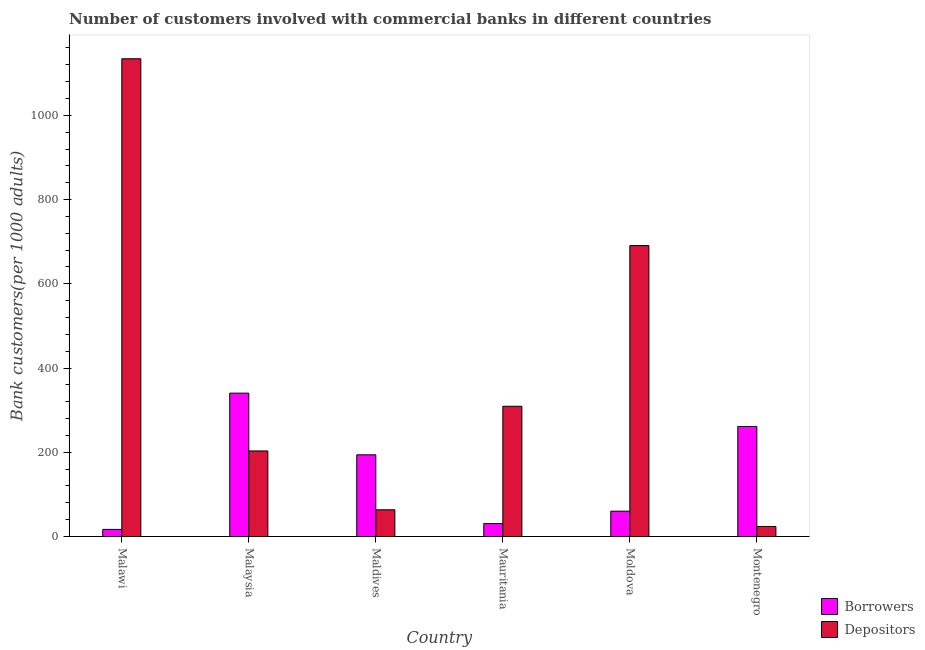Are the number of bars per tick equal to the number of legend labels?
Keep it short and to the point. Yes. Are the number of bars on each tick of the X-axis equal?
Ensure brevity in your answer.  Yes. How many bars are there on the 5th tick from the right?
Keep it short and to the point. 2. What is the label of the 5th group of bars from the left?
Your response must be concise. Moldova. What is the number of borrowers in Maldives?
Provide a succinct answer. 193.96. Across all countries, what is the maximum number of borrowers?
Keep it short and to the point. 340.42. Across all countries, what is the minimum number of borrowers?
Your answer should be very brief. 16.9. In which country was the number of depositors maximum?
Provide a short and direct response. Malawi. In which country was the number of borrowers minimum?
Give a very brief answer. Malawi. What is the total number of depositors in the graph?
Offer a terse response. 2424.78. What is the difference between the number of depositors in Malaysia and that in Maldives?
Your response must be concise. 139.73. What is the difference between the number of depositors in Maldives and the number of borrowers in Mauritania?
Give a very brief answer. 32.75. What is the average number of borrowers per country?
Offer a terse response. 150.55. What is the difference between the number of borrowers and number of depositors in Mauritania?
Make the answer very short. -278.55. In how many countries, is the number of depositors greater than 120 ?
Keep it short and to the point. 4. What is the ratio of the number of depositors in Malawi to that in Maldives?
Provide a succinct answer. 17.88. Is the number of depositors in Maldives less than that in Moldova?
Your response must be concise. Yes. Is the difference between the number of borrowers in Malaysia and Moldova greater than the difference between the number of depositors in Malaysia and Moldova?
Keep it short and to the point. Yes. What is the difference between the highest and the second highest number of depositors?
Provide a short and direct response. 443.6. What is the difference between the highest and the lowest number of borrowers?
Give a very brief answer. 323.52. Is the sum of the number of depositors in Malaysia and Montenegro greater than the maximum number of borrowers across all countries?
Keep it short and to the point. No. What does the 1st bar from the left in Moldova represents?
Your answer should be compact. Borrowers. What does the 1st bar from the right in Maldives represents?
Offer a very short reply. Depositors. Are all the bars in the graph horizontal?
Your response must be concise. No. What is the difference between two consecutive major ticks on the Y-axis?
Your answer should be very brief. 200. Does the graph contain any zero values?
Keep it short and to the point. No. Where does the legend appear in the graph?
Provide a succinct answer. Bottom right. How many legend labels are there?
Offer a terse response. 2. What is the title of the graph?
Your answer should be very brief. Number of customers involved with commercial banks in different countries. What is the label or title of the X-axis?
Your response must be concise. Country. What is the label or title of the Y-axis?
Provide a short and direct response. Bank customers(per 1000 adults). What is the Bank customers(per 1000 adults) of Borrowers in Malawi?
Your response must be concise. 16.9. What is the Bank customers(per 1000 adults) in Depositors in Malawi?
Your answer should be very brief. 1134.4. What is the Bank customers(per 1000 adults) in Borrowers in Malaysia?
Provide a succinct answer. 340.42. What is the Bank customers(per 1000 adults) in Depositors in Malaysia?
Keep it short and to the point. 203.17. What is the Bank customers(per 1000 adults) of Borrowers in Maldives?
Your response must be concise. 193.96. What is the Bank customers(per 1000 adults) of Depositors in Maldives?
Provide a succinct answer. 63.43. What is the Bank customers(per 1000 adults) of Borrowers in Mauritania?
Provide a short and direct response. 30.68. What is the Bank customers(per 1000 adults) in Depositors in Mauritania?
Your answer should be compact. 309.23. What is the Bank customers(per 1000 adults) of Borrowers in Moldova?
Ensure brevity in your answer.  60.13. What is the Bank customers(per 1000 adults) of Depositors in Moldova?
Provide a short and direct response. 690.79. What is the Bank customers(per 1000 adults) in Borrowers in Montenegro?
Offer a terse response. 261.24. What is the Bank customers(per 1000 adults) of Depositors in Montenegro?
Ensure brevity in your answer.  23.75. Across all countries, what is the maximum Bank customers(per 1000 adults) in Borrowers?
Provide a short and direct response. 340.42. Across all countries, what is the maximum Bank customers(per 1000 adults) in Depositors?
Provide a short and direct response. 1134.4. Across all countries, what is the minimum Bank customers(per 1000 adults) in Borrowers?
Provide a succinct answer. 16.9. Across all countries, what is the minimum Bank customers(per 1000 adults) in Depositors?
Keep it short and to the point. 23.75. What is the total Bank customers(per 1000 adults) of Borrowers in the graph?
Provide a short and direct response. 903.32. What is the total Bank customers(per 1000 adults) of Depositors in the graph?
Make the answer very short. 2424.78. What is the difference between the Bank customers(per 1000 adults) in Borrowers in Malawi and that in Malaysia?
Your response must be concise. -323.52. What is the difference between the Bank customers(per 1000 adults) of Depositors in Malawi and that in Malaysia?
Offer a terse response. 931.23. What is the difference between the Bank customers(per 1000 adults) in Borrowers in Malawi and that in Maldives?
Offer a very short reply. -177.07. What is the difference between the Bank customers(per 1000 adults) in Depositors in Malawi and that in Maldives?
Your answer should be very brief. 1070.96. What is the difference between the Bank customers(per 1000 adults) of Borrowers in Malawi and that in Mauritania?
Make the answer very short. -13.79. What is the difference between the Bank customers(per 1000 adults) of Depositors in Malawi and that in Mauritania?
Provide a short and direct response. 825.16. What is the difference between the Bank customers(per 1000 adults) of Borrowers in Malawi and that in Moldova?
Ensure brevity in your answer.  -43.24. What is the difference between the Bank customers(per 1000 adults) of Depositors in Malawi and that in Moldova?
Offer a very short reply. 443.6. What is the difference between the Bank customers(per 1000 adults) in Borrowers in Malawi and that in Montenegro?
Make the answer very short. -244.34. What is the difference between the Bank customers(per 1000 adults) in Depositors in Malawi and that in Montenegro?
Offer a terse response. 1110.65. What is the difference between the Bank customers(per 1000 adults) of Borrowers in Malaysia and that in Maldives?
Your answer should be very brief. 146.45. What is the difference between the Bank customers(per 1000 adults) of Depositors in Malaysia and that in Maldives?
Give a very brief answer. 139.73. What is the difference between the Bank customers(per 1000 adults) in Borrowers in Malaysia and that in Mauritania?
Offer a very short reply. 309.73. What is the difference between the Bank customers(per 1000 adults) of Depositors in Malaysia and that in Mauritania?
Give a very brief answer. -106.06. What is the difference between the Bank customers(per 1000 adults) in Borrowers in Malaysia and that in Moldova?
Your response must be concise. 280.28. What is the difference between the Bank customers(per 1000 adults) in Depositors in Malaysia and that in Moldova?
Provide a short and direct response. -487.63. What is the difference between the Bank customers(per 1000 adults) in Borrowers in Malaysia and that in Montenegro?
Give a very brief answer. 79.18. What is the difference between the Bank customers(per 1000 adults) in Depositors in Malaysia and that in Montenegro?
Make the answer very short. 179.42. What is the difference between the Bank customers(per 1000 adults) of Borrowers in Maldives and that in Mauritania?
Keep it short and to the point. 163.28. What is the difference between the Bank customers(per 1000 adults) in Depositors in Maldives and that in Mauritania?
Keep it short and to the point. -245.8. What is the difference between the Bank customers(per 1000 adults) of Borrowers in Maldives and that in Moldova?
Ensure brevity in your answer.  133.83. What is the difference between the Bank customers(per 1000 adults) of Depositors in Maldives and that in Moldova?
Your answer should be compact. -627.36. What is the difference between the Bank customers(per 1000 adults) of Borrowers in Maldives and that in Montenegro?
Provide a succinct answer. -67.27. What is the difference between the Bank customers(per 1000 adults) in Depositors in Maldives and that in Montenegro?
Your response must be concise. 39.69. What is the difference between the Bank customers(per 1000 adults) of Borrowers in Mauritania and that in Moldova?
Give a very brief answer. -29.45. What is the difference between the Bank customers(per 1000 adults) of Depositors in Mauritania and that in Moldova?
Keep it short and to the point. -381.56. What is the difference between the Bank customers(per 1000 adults) in Borrowers in Mauritania and that in Montenegro?
Give a very brief answer. -230.55. What is the difference between the Bank customers(per 1000 adults) in Depositors in Mauritania and that in Montenegro?
Keep it short and to the point. 285.49. What is the difference between the Bank customers(per 1000 adults) in Borrowers in Moldova and that in Montenegro?
Your answer should be compact. -201.1. What is the difference between the Bank customers(per 1000 adults) of Depositors in Moldova and that in Montenegro?
Offer a very short reply. 667.05. What is the difference between the Bank customers(per 1000 adults) in Borrowers in Malawi and the Bank customers(per 1000 adults) in Depositors in Malaysia?
Keep it short and to the point. -186.27. What is the difference between the Bank customers(per 1000 adults) of Borrowers in Malawi and the Bank customers(per 1000 adults) of Depositors in Maldives?
Provide a succinct answer. -46.54. What is the difference between the Bank customers(per 1000 adults) of Borrowers in Malawi and the Bank customers(per 1000 adults) of Depositors in Mauritania?
Your response must be concise. -292.34. What is the difference between the Bank customers(per 1000 adults) of Borrowers in Malawi and the Bank customers(per 1000 adults) of Depositors in Moldova?
Give a very brief answer. -673.9. What is the difference between the Bank customers(per 1000 adults) in Borrowers in Malawi and the Bank customers(per 1000 adults) in Depositors in Montenegro?
Your response must be concise. -6.85. What is the difference between the Bank customers(per 1000 adults) of Borrowers in Malaysia and the Bank customers(per 1000 adults) of Depositors in Maldives?
Provide a short and direct response. 276.98. What is the difference between the Bank customers(per 1000 adults) in Borrowers in Malaysia and the Bank customers(per 1000 adults) in Depositors in Mauritania?
Ensure brevity in your answer.  31.18. What is the difference between the Bank customers(per 1000 adults) of Borrowers in Malaysia and the Bank customers(per 1000 adults) of Depositors in Moldova?
Provide a short and direct response. -350.38. What is the difference between the Bank customers(per 1000 adults) of Borrowers in Malaysia and the Bank customers(per 1000 adults) of Depositors in Montenegro?
Your response must be concise. 316.67. What is the difference between the Bank customers(per 1000 adults) in Borrowers in Maldives and the Bank customers(per 1000 adults) in Depositors in Mauritania?
Your response must be concise. -115.27. What is the difference between the Bank customers(per 1000 adults) in Borrowers in Maldives and the Bank customers(per 1000 adults) in Depositors in Moldova?
Ensure brevity in your answer.  -496.83. What is the difference between the Bank customers(per 1000 adults) of Borrowers in Maldives and the Bank customers(per 1000 adults) of Depositors in Montenegro?
Provide a succinct answer. 170.21. What is the difference between the Bank customers(per 1000 adults) in Borrowers in Mauritania and the Bank customers(per 1000 adults) in Depositors in Moldova?
Your answer should be compact. -660.11. What is the difference between the Bank customers(per 1000 adults) in Borrowers in Mauritania and the Bank customers(per 1000 adults) in Depositors in Montenegro?
Offer a terse response. 6.93. What is the difference between the Bank customers(per 1000 adults) of Borrowers in Moldova and the Bank customers(per 1000 adults) of Depositors in Montenegro?
Offer a terse response. 36.39. What is the average Bank customers(per 1000 adults) in Borrowers per country?
Keep it short and to the point. 150.55. What is the average Bank customers(per 1000 adults) of Depositors per country?
Your answer should be very brief. 404.13. What is the difference between the Bank customers(per 1000 adults) of Borrowers and Bank customers(per 1000 adults) of Depositors in Malawi?
Offer a very short reply. -1117.5. What is the difference between the Bank customers(per 1000 adults) in Borrowers and Bank customers(per 1000 adults) in Depositors in Malaysia?
Your response must be concise. 137.25. What is the difference between the Bank customers(per 1000 adults) in Borrowers and Bank customers(per 1000 adults) in Depositors in Maldives?
Offer a terse response. 130.53. What is the difference between the Bank customers(per 1000 adults) in Borrowers and Bank customers(per 1000 adults) in Depositors in Mauritania?
Ensure brevity in your answer.  -278.55. What is the difference between the Bank customers(per 1000 adults) of Borrowers and Bank customers(per 1000 adults) of Depositors in Moldova?
Make the answer very short. -630.66. What is the difference between the Bank customers(per 1000 adults) of Borrowers and Bank customers(per 1000 adults) of Depositors in Montenegro?
Your answer should be very brief. 237.49. What is the ratio of the Bank customers(per 1000 adults) of Borrowers in Malawi to that in Malaysia?
Your answer should be compact. 0.05. What is the ratio of the Bank customers(per 1000 adults) in Depositors in Malawi to that in Malaysia?
Offer a very short reply. 5.58. What is the ratio of the Bank customers(per 1000 adults) of Borrowers in Malawi to that in Maldives?
Give a very brief answer. 0.09. What is the ratio of the Bank customers(per 1000 adults) in Depositors in Malawi to that in Maldives?
Provide a short and direct response. 17.88. What is the ratio of the Bank customers(per 1000 adults) of Borrowers in Malawi to that in Mauritania?
Make the answer very short. 0.55. What is the ratio of the Bank customers(per 1000 adults) in Depositors in Malawi to that in Mauritania?
Provide a short and direct response. 3.67. What is the ratio of the Bank customers(per 1000 adults) in Borrowers in Malawi to that in Moldova?
Keep it short and to the point. 0.28. What is the ratio of the Bank customers(per 1000 adults) of Depositors in Malawi to that in Moldova?
Offer a terse response. 1.64. What is the ratio of the Bank customers(per 1000 adults) of Borrowers in Malawi to that in Montenegro?
Your response must be concise. 0.06. What is the ratio of the Bank customers(per 1000 adults) in Depositors in Malawi to that in Montenegro?
Make the answer very short. 47.77. What is the ratio of the Bank customers(per 1000 adults) in Borrowers in Malaysia to that in Maldives?
Your response must be concise. 1.76. What is the ratio of the Bank customers(per 1000 adults) of Depositors in Malaysia to that in Maldives?
Provide a succinct answer. 3.2. What is the ratio of the Bank customers(per 1000 adults) of Borrowers in Malaysia to that in Mauritania?
Offer a terse response. 11.1. What is the ratio of the Bank customers(per 1000 adults) of Depositors in Malaysia to that in Mauritania?
Your response must be concise. 0.66. What is the ratio of the Bank customers(per 1000 adults) of Borrowers in Malaysia to that in Moldova?
Provide a short and direct response. 5.66. What is the ratio of the Bank customers(per 1000 adults) of Depositors in Malaysia to that in Moldova?
Provide a short and direct response. 0.29. What is the ratio of the Bank customers(per 1000 adults) in Borrowers in Malaysia to that in Montenegro?
Make the answer very short. 1.3. What is the ratio of the Bank customers(per 1000 adults) in Depositors in Malaysia to that in Montenegro?
Offer a terse response. 8.56. What is the ratio of the Bank customers(per 1000 adults) in Borrowers in Maldives to that in Mauritania?
Your answer should be compact. 6.32. What is the ratio of the Bank customers(per 1000 adults) in Depositors in Maldives to that in Mauritania?
Ensure brevity in your answer.  0.21. What is the ratio of the Bank customers(per 1000 adults) in Borrowers in Maldives to that in Moldova?
Offer a very short reply. 3.23. What is the ratio of the Bank customers(per 1000 adults) of Depositors in Maldives to that in Moldova?
Keep it short and to the point. 0.09. What is the ratio of the Bank customers(per 1000 adults) of Borrowers in Maldives to that in Montenegro?
Your response must be concise. 0.74. What is the ratio of the Bank customers(per 1000 adults) in Depositors in Maldives to that in Montenegro?
Ensure brevity in your answer.  2.67. What is the ratio of the Bank customers(per 1000 adults) of Borrowers in Mauritania to that in Moldova?
Make the answer very short. 0.51. What is the ratio of the Bank customers(per 1000 adults) of Depositors in Mauritania to that in Moldova?
Provide a succinct answer. 0.45. What is the ratio of the Bank customers(per 1000 adults) of Borrowers in Mauritania to that in Montenegro?
Offer a very short reply. 0.12. What is the ratio of the Bank customers(per 1000 adults) in Depositors in Mauritania to that in Montenegro?
Offer a terse response. 13.02. What is the ratio of the Bank customers(per 1000 adults) in Borrowers in Moldova to that in Montenegro?
Your answer should be very brief. 0.23. What is the ratio of the Bank customers(per 1000 adults) in Depositors in Moldova to that in Montenegro?
Offer a very short reply. 29.09. What is the difference between the highest and the second highest Bank customers(per 1000 adults) of Borrowers?
Your answer should be compact. 79.18. What is the difference between the highest and the second highest Bank customers(per 1000 adults) in Depositors?
Provide a succinct answer. 443.6. What is the difference between the highest and the lowest Bank customers(per 1000 adults) of Borrowers?
Ensure brevity in your answer.  323.52. What is the difference between the highest and the lowest Bank customers(per 1000 adults) of Depositors?
Make the answer very short. 1110.65. 